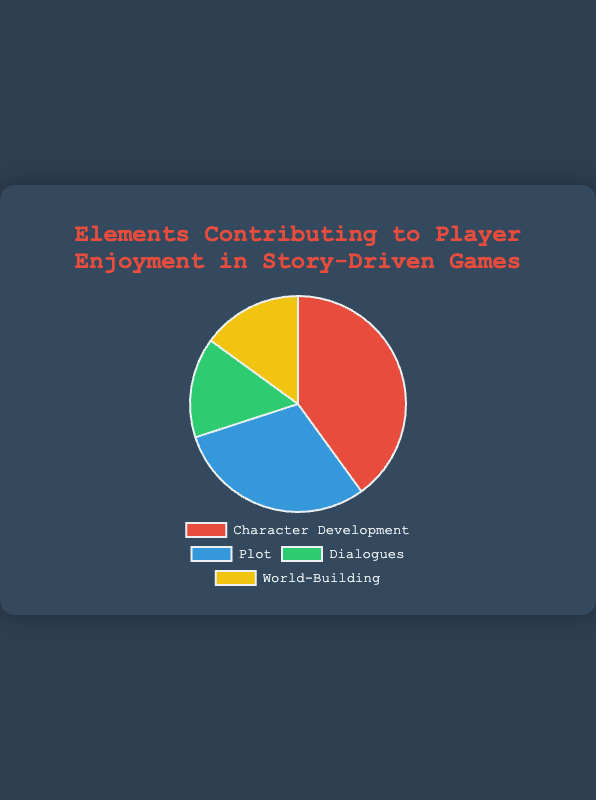what is the most crucial element contributing to player enjoyment according to the pie chart? Character Development is the largest slice in the pie chart, contributing 40%, which is the highest percentage among all elements.
Answer: Character Development how much in total do plot and dialogues contribute to player enjoyment? Plot contributes 30% and Dialogues contribute 15%, summing them gives 30% + 15% = 45%.
Answer: 45% which element contributes equally to player enjoyment? Dialogues and World-Building each contribute 15%.
Answer: Dialogues and World-Building which element contributes the least to player enjoyment? Dialogues and World-Building both have the smallest percentage at 15%.
Answer: Dialogues and World-Building what is the combined contribution of character development and world-building? Character Development contributes 40% and World-Building contributes 15%. Combined, they contribute 40% + 15% = 55%.
Answer: 55% how much more does character development contribute than dialogues? Character Development contributes 40%, while Dialogues contribute 15%. The difference is 40% - 15% = 25%.
Answer: 25% which two elements together make up exactly half of the total player enjoyment? Plot and Character Development together contribute 30% + 40% = 70%, which is more than half. Dialogues and World-Building combined contribute 15% + 15% = 30%, which is less than half. Hence, no combination of two elements makes up exactly half.
Answer: None if character development and plot made up all of the player enjoyment, what percentage would each have? Together, Character Development and Plot contribute 40% + 30% = 70%. If they made up 100% of enjoyment, the new percentages would be (40/70 * 100)% for Character Development and (30/70 * 100)% for Plot, which simplifies to approximately 57.14% and 42.86%, respectively.
Answer: 57.14%, 42.86% based on the pie chart, what proportion of player enjoyment is not from plot? Plot contributes 30%. Therefore, the proportion not from Plot is 100% - 30% = 70%.
Answer: 70% 